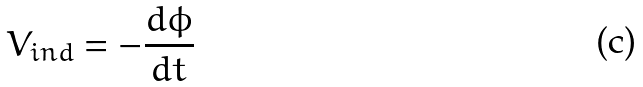Convert formula to latex. <formula><loc_0><loc_0><loc_500><loc_500>V _ { i n d } = - \frac { d \phi } { d t }</formula> 